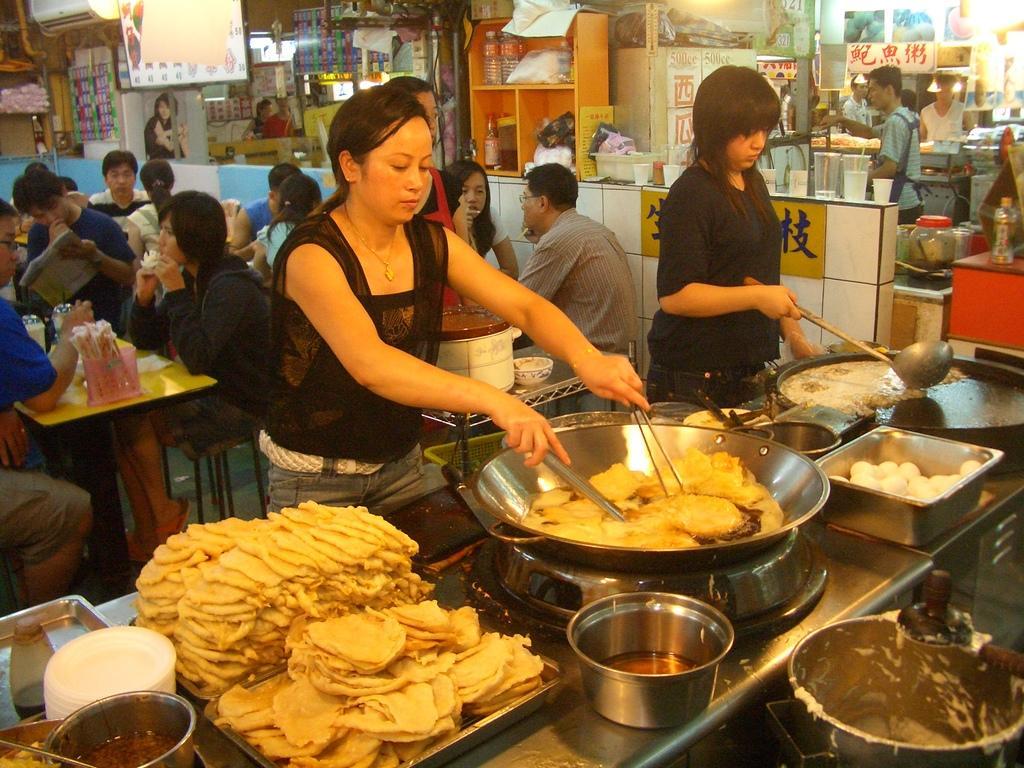Can you describe this image briefly? In this image there are a group of people some of them are sitting and some of them are standing, in the foreground there are two persons who are standing and they are cooking something. In front of them there is one table, on the table there are some food items, vessels, bowls and some other objects. In the background there are some stores and some persons are standing and also we could see some tables, glasses, cups, plastic bottles and some other objects. 